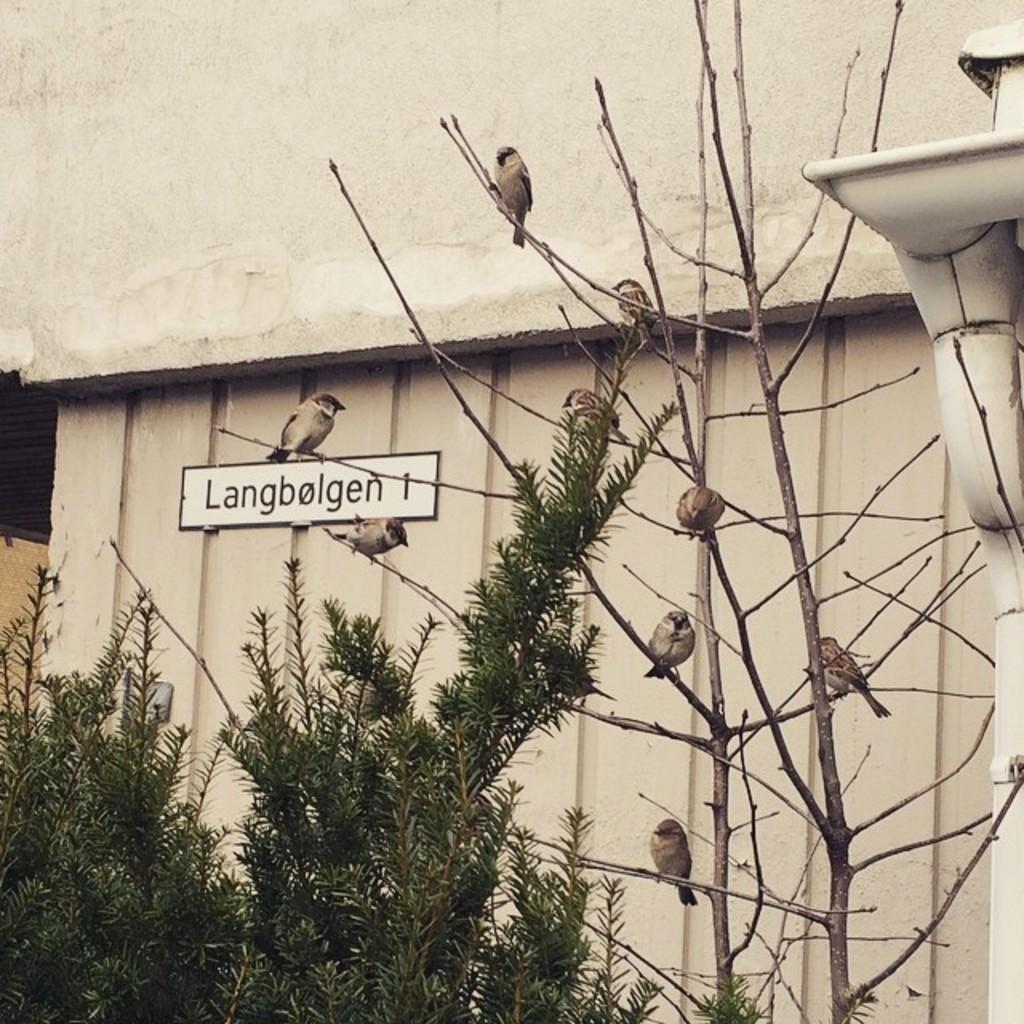What type of animals can be seen in the image? There are birds on branches in the image. What type of vegetation is present in the image? There are trees in the image. What man-made object can be seen in the image? There is a pipe in the image. What is located on the wall in the background of the image? There is a name board on a wall in the background of the image. What type of disease can be seen spreading among the birds in the image? There is no indication of any disease among the birds in the image; they are simply perched on branches. 